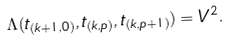Convert formula to latex. <formula><loc_0><loc_0><loc_500><loc_500>\Lambda ( t _ { ( k + 1 , 0 ) } , t _ { ( k , p ) } , t _ { ( k , p + 1 ) } ) = V ^ { 2 } .</formula> 